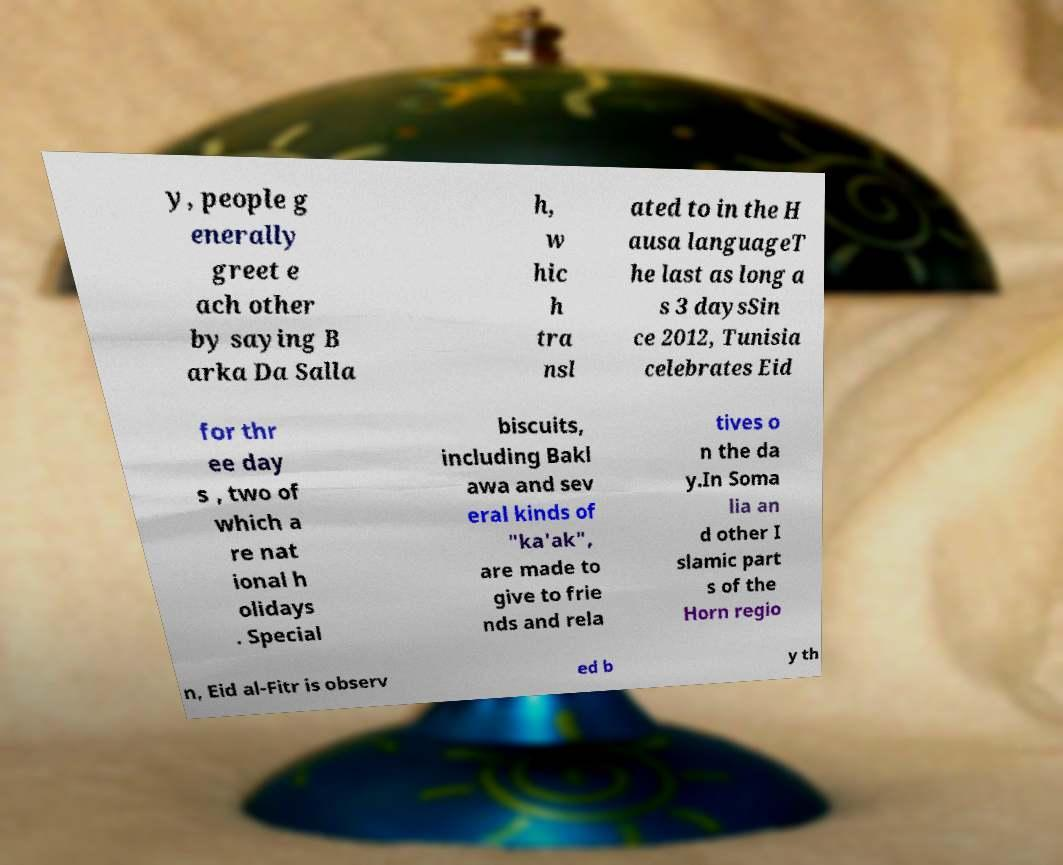Can you read and provide the text displayed in the image?This photo seems to have some interesting text. Can you extract and type it out for me? y, people g enerally greet e ach other by saying B arka Da Salla h, w hic h tra nsl ated to in the H ausa languageT he last as long a s 3 daysSin ce 2012, Tunisia celebrates Eid for thr ee day s , two of which a re nat ional h olidays . Special biscuits, including Bakl awa and sev eral kinds of "ka'ak", are made to give to frie nds and rela tives o n the da y.In Soma lia an d other I slamic part s of the Horn regio n, Eid al-Fitr is observ ed b y th 